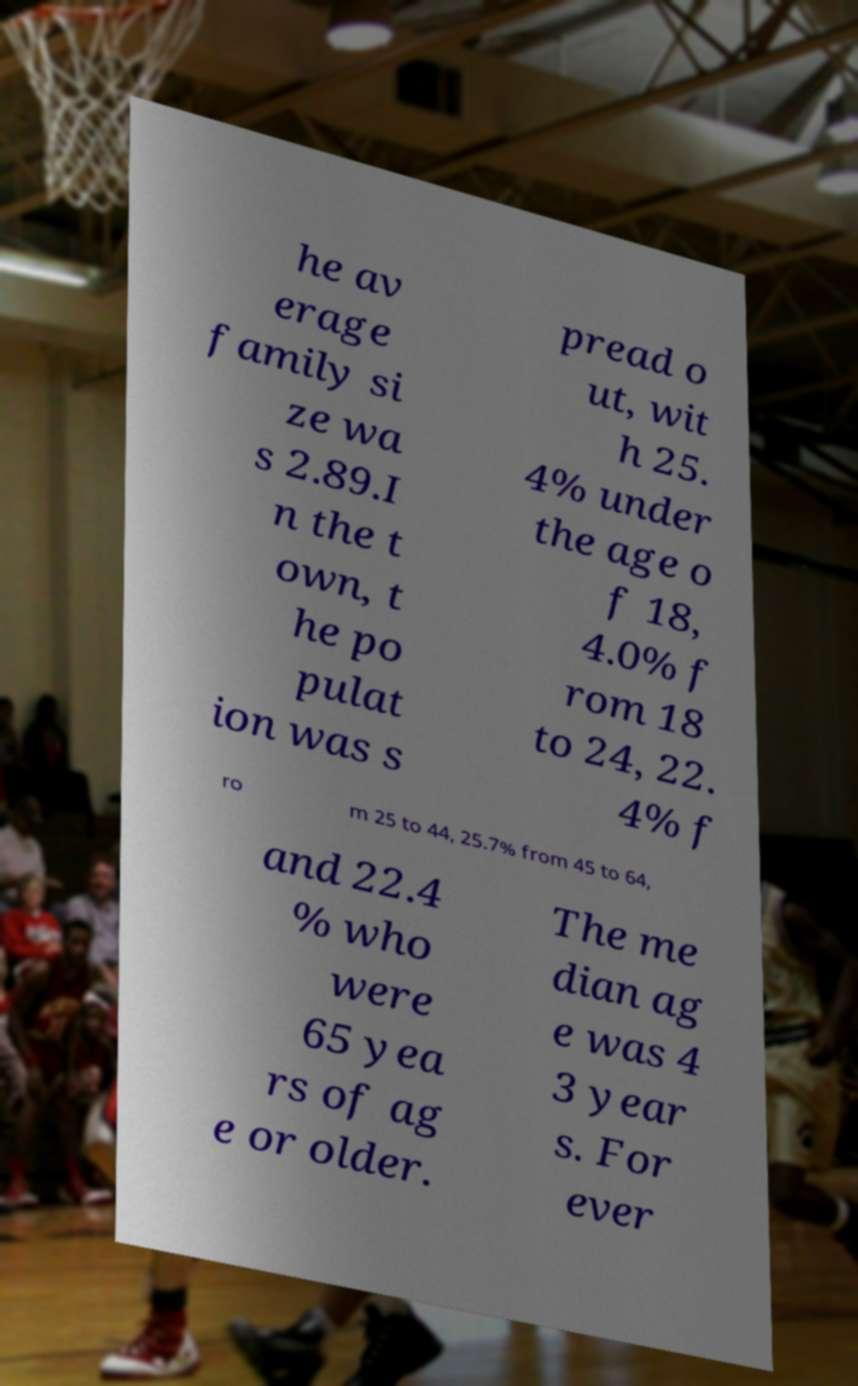Can you accurately transcribe the text from the provided image for me? he av erage family si ze wa s 2.89.I n the t own, t he po pulat ion was s pread o ut, wit h 25. 4% under the age o f 18, 4.0% f rom 18 to 24, 22. 4% f ro m 25 to 44, 25.7% from 45 to 64, and 22.4 % who were 65 yea rs of ag e or older. The me dian ag e was 4 3 year s. For ever 